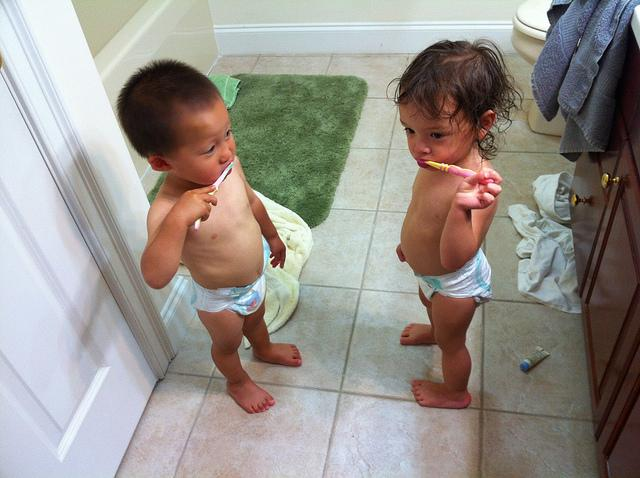How is the kid on the right brushing his teeth differently from the kid on the left? left handed 